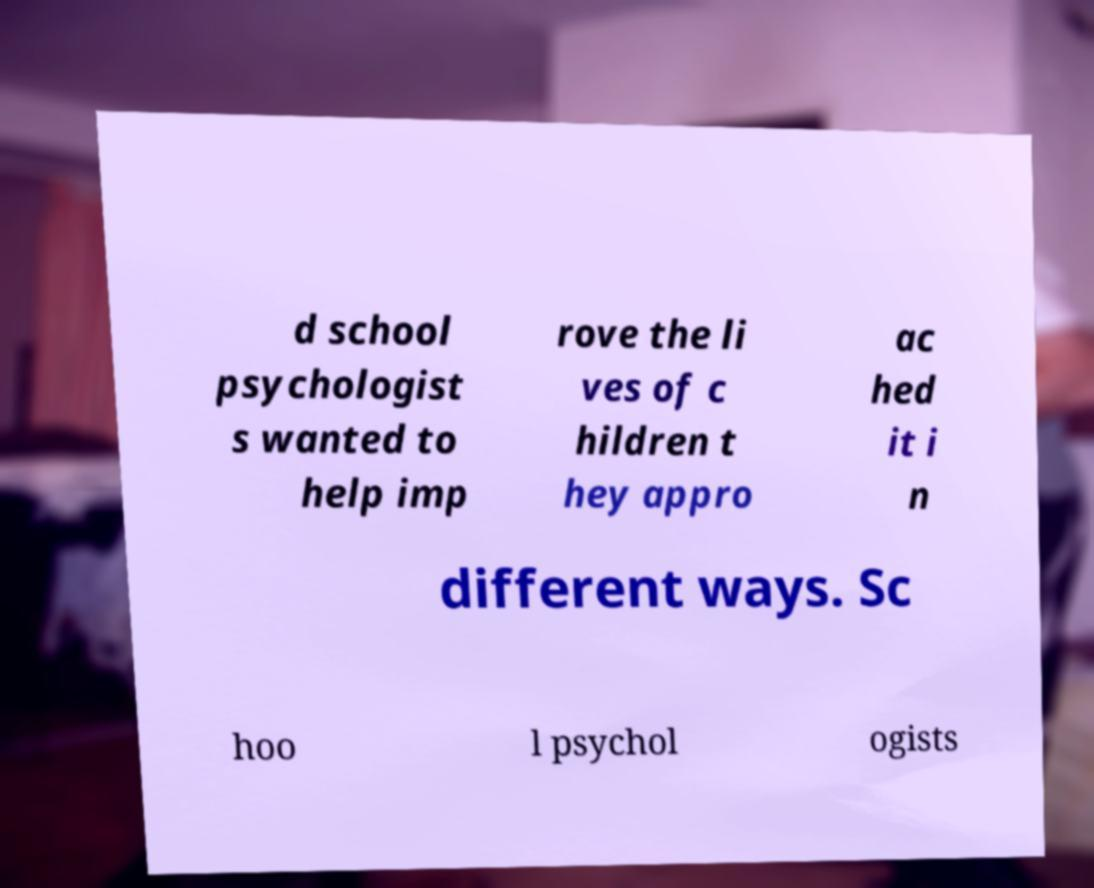There's text embedded in this image that I need extracted. Can you transcribe it verbatim? d school psychologist s wanted to help imp rove the li ves of c hildren t hey appro ac hed it i n different ways. Sc hoo l psychol ogists 